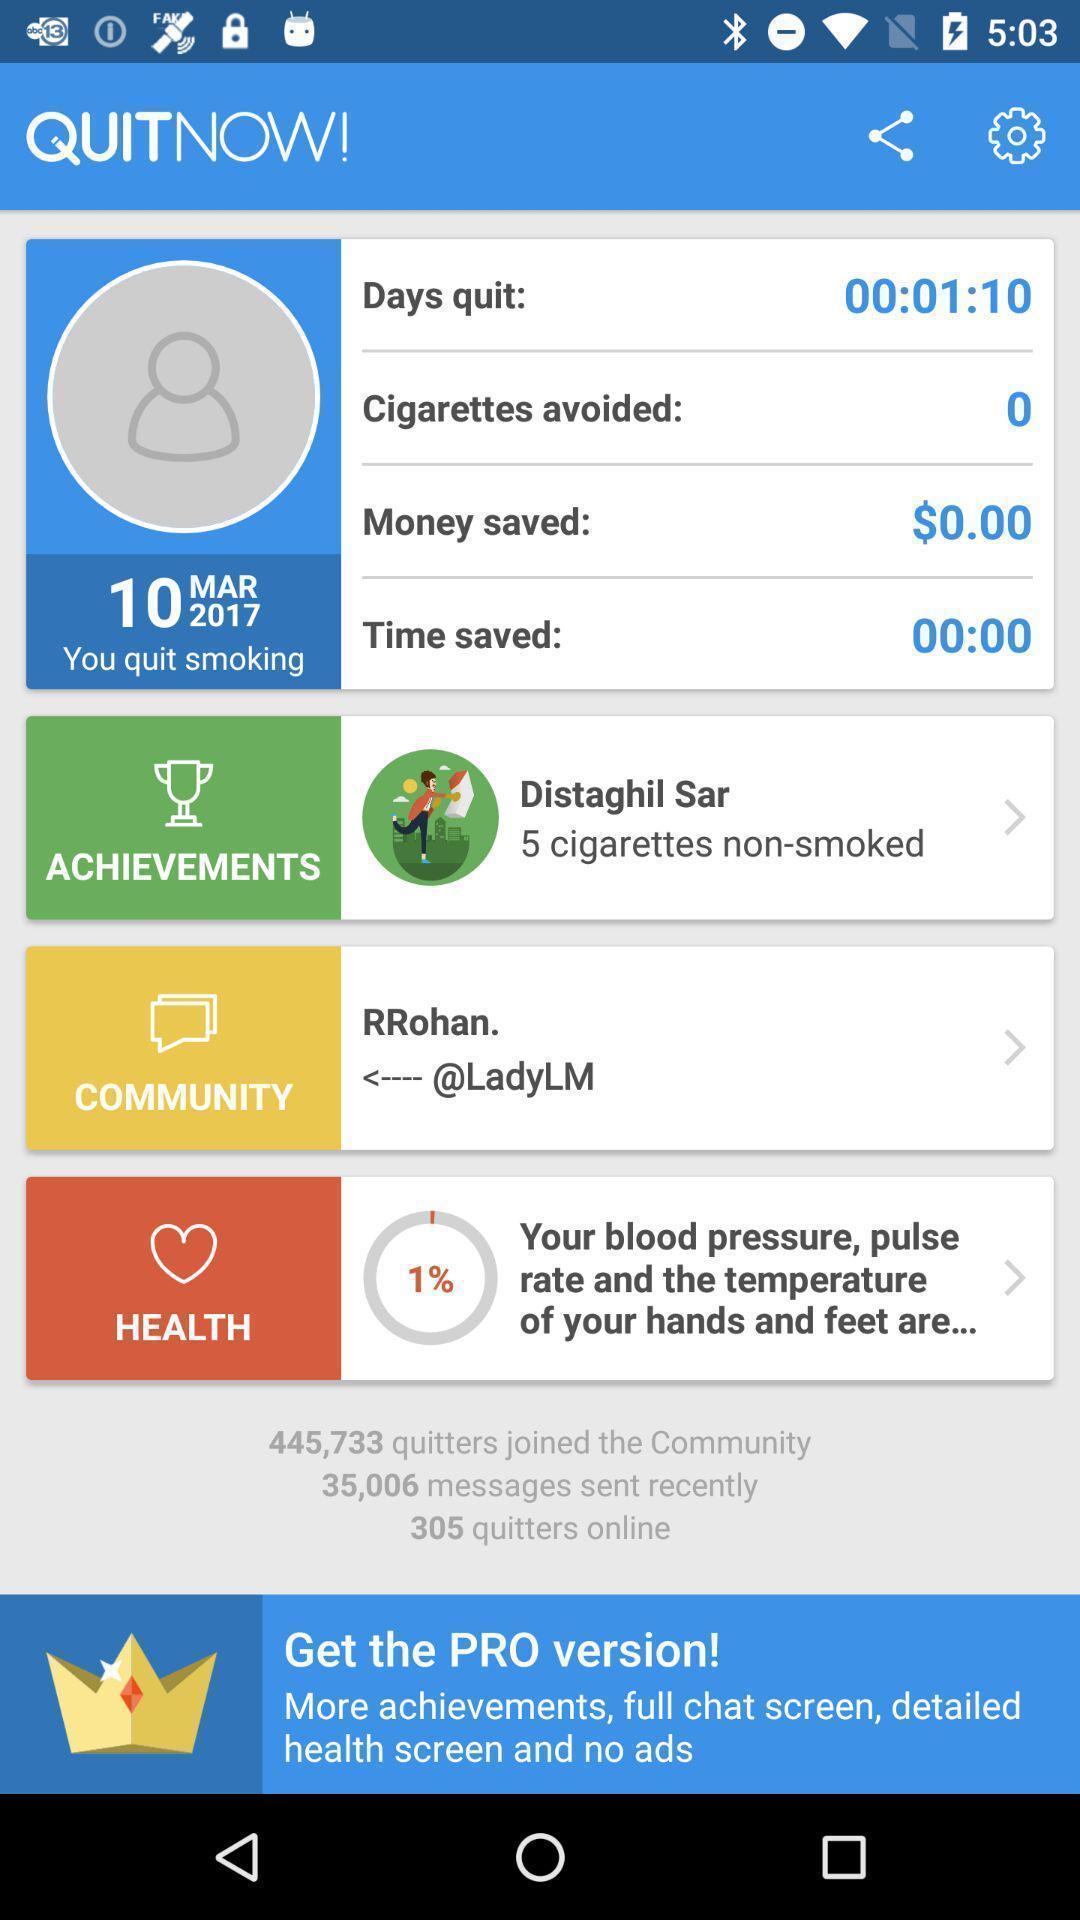Give me a summary of this screen capture. Screen showing profile details in a smoking app. 